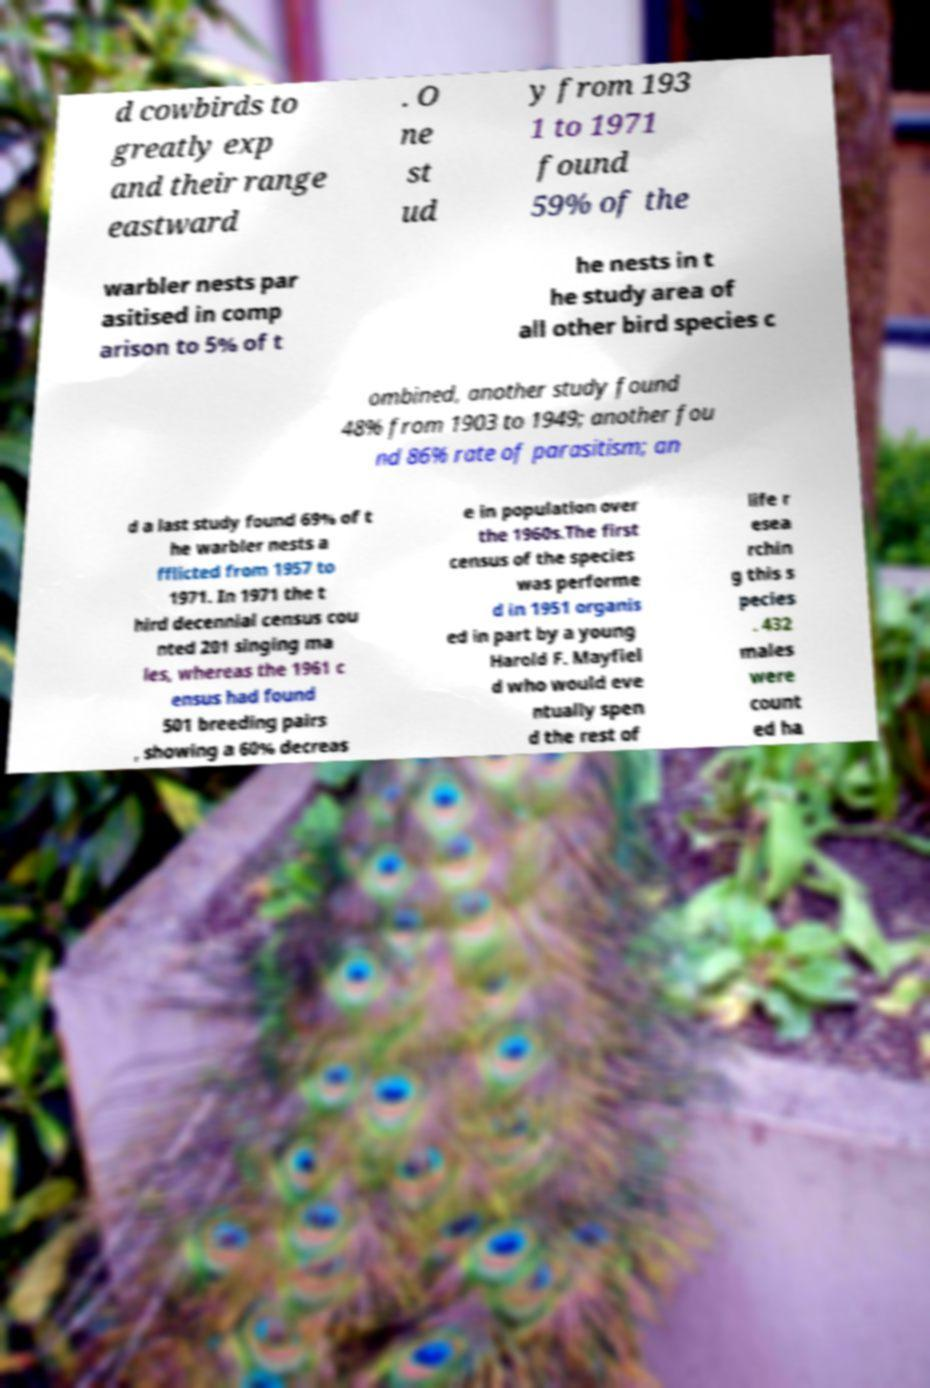Can you read and provide the text displayed in the image?This photo seems to have some interesting text. Can you extract and type it out for me? d cowbirds to greatly exp and their range eastward . O ne st ud y from 193 1 to 1971 found 59% of the warbler nests par asitised in comp arison to 5% of t he nests in t he study area of all other bird species c ombined, another study found 48% from 1903 to 1949; another fou nd 86% rate of parasitism; an d a last study found 69% of t he warbler nests a fflicted from 1957 to 1971. In 1971 the t hird decennial census cou nted 201 singing ma les, whereas the 1961 c ensus had found 501 breeding pairs , showing a 60% decreas e in population over the 1960s.The first census of the species was performe d in 1951 organis ed in part by a young Harold F. Mayfiel d who would eve ntually spen d the rest of life r esea rchin g this s pecies . 432 males were count ed ha 